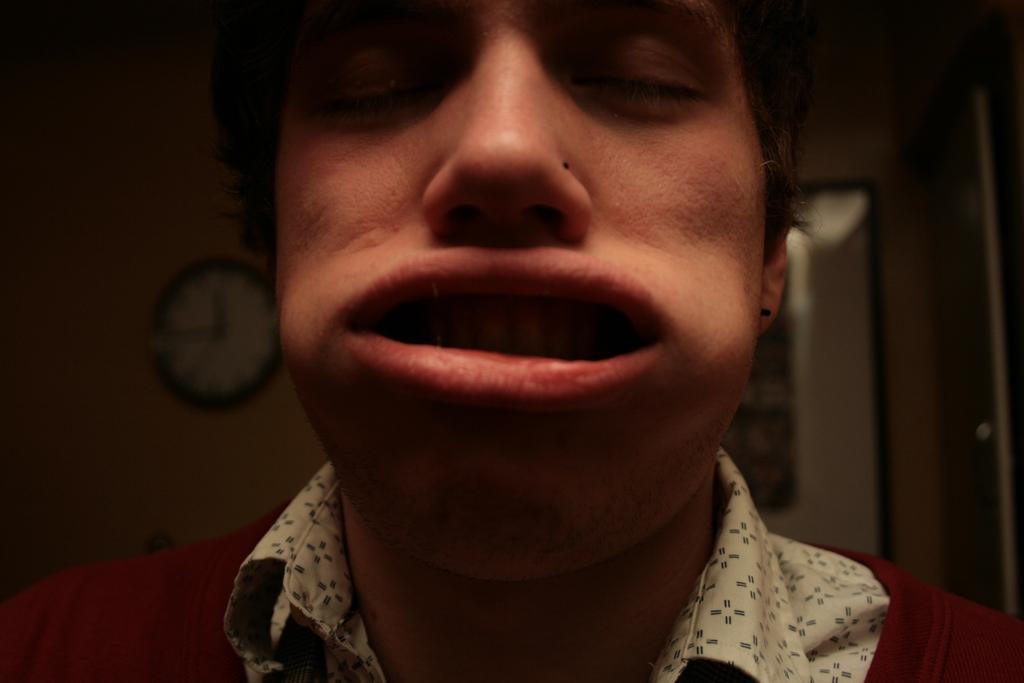In one or two sentences, can you explain what this image depicts? There is a person closing his eyes and is having weird expression. In the background, there is a clock on the wall. And the background is dark in color. 